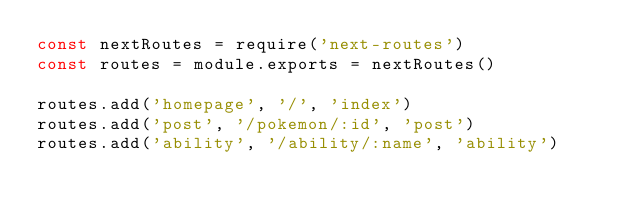<code> <loc_0><loc_0><loc_500><loc_500><_JavaScript_>const nextRoutes = require('next-routes')
const routes = module.exports = nextRoutes()

routes.add('homepage', '/', 'index')
routes.add('post', '/pokemon/:id', 'post')
routes.add('ability', '/ability/:name', 'ability')
</code> 